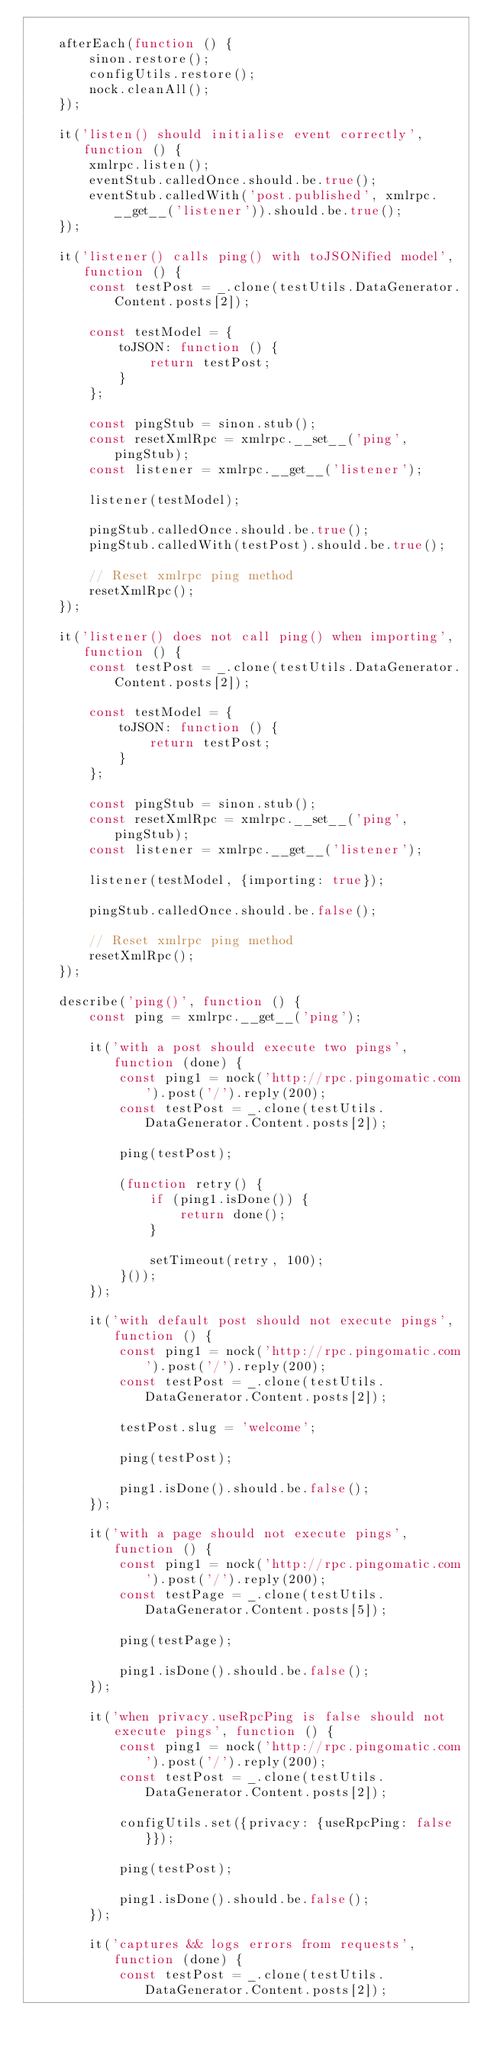<code> <loc_0><loc_0><loc_500><loc_500><_JavaScript_>
    afterEach(function () {
        sinon.restore();
        configUtils.restore();
        nock.cleanAll();
    });

    it('listen() should initialise event correctly', function () {
        xmlrpc.listen();
        eventStub.calledOnce.should.be.true();
        eventStub.calledWith('post.published', xmlrpc.__get__('listener')).should.be.true();
    });

    it('listener() calls ping() with toJSONified model', function () {
        const testPost = _.clone(testUtils.DataGenerator.Content.posts[2]);

        const testModel = {
            toJSON: function () {
                return testPost;
            }
        };

        const pingStub = sinon.stub();
        const resetXmlRpc = xmlrpc.__set__('ping', pingStub);
        const listener = xmlrpc.__get__('listener');

        listener(testModel);

        pingStub.calledOnce.should.be.true();
        pingStub.calledWith(testPost).should.be.true();

        // Reset xmlrpc ping method
        resetXmlRpc();
    });

    it('listener() does not call ping() when importing', function () {
        const testPost = _.clone(testUtils.DataGenerator.Content.posts[2]);

        const testModel = {
            toJSON: function () {
                return testPost;
            }
        };

        const pingStub = sinon.stub();
        const resetXmlRpc = xmlrpc.__set__('ping', pingStub);
        const listener = xmlrpc.__get__('listener');

        listener(testModel, {importing: true});

        pingStub.calledOnce.should.be.false();

        // Reset xmlrpc ping method
        resetXmlRpc();
    });

    describe('ping()', function () {
        const ping = xmlrpc.__get__('ping');

        it('with a post should execute two pings', function (done) {
            const ping1 = nock('http://rpc.pingomatic.com').post('/').reply(200);
            const testPost = _.clone(testUtils.DataGenerator.Content.posts[2]);

            ping(testPost);

            (function retry() {
                if (ping1.isDone()) {
                    return done();
                }

                setTimeout(retry, 100);
            }());
        });

        it('with default post should not execute pings', function () {
            const ping1 = nock('http://rpc.pingomatic.com').post('/').reply(200);
            const testPost = _.clone(testUtils.DataGenerator.Content.posts[2]);

            testPost.slug = 'welcome';

            ping(testPost);

            ping1.isDone().should.be.false();
        });

        it('with a page should not execute pings', function () {
            const ping1 = nock('http://rpc.pingomatic.com').post('/').reply(200);
            const testPage = _.clone(testUtils.DataGenerator.Content.posts[5]);

            ping(testPage);

            ping1.isDone().should.be.false();
        });

        it('when privacy.useRpcPing is false should not execute pings', function () {
            const ping1 = nock('http://rpc.pingomatic.com').post('/').reply(200);
            const testPost = _.clone(testUtils.DataGenerator.Content.posts[2]);

            configUtils.set({privacy: {useRpcPing: false}});

            ping(testPost);

            ping1.isDone().should.be.false();
        });

        it('captures && logs errors from requests', function (done) {
            const testPost = _.clone(testUtils.DataGenerator.Content.posts[2]);</code> 